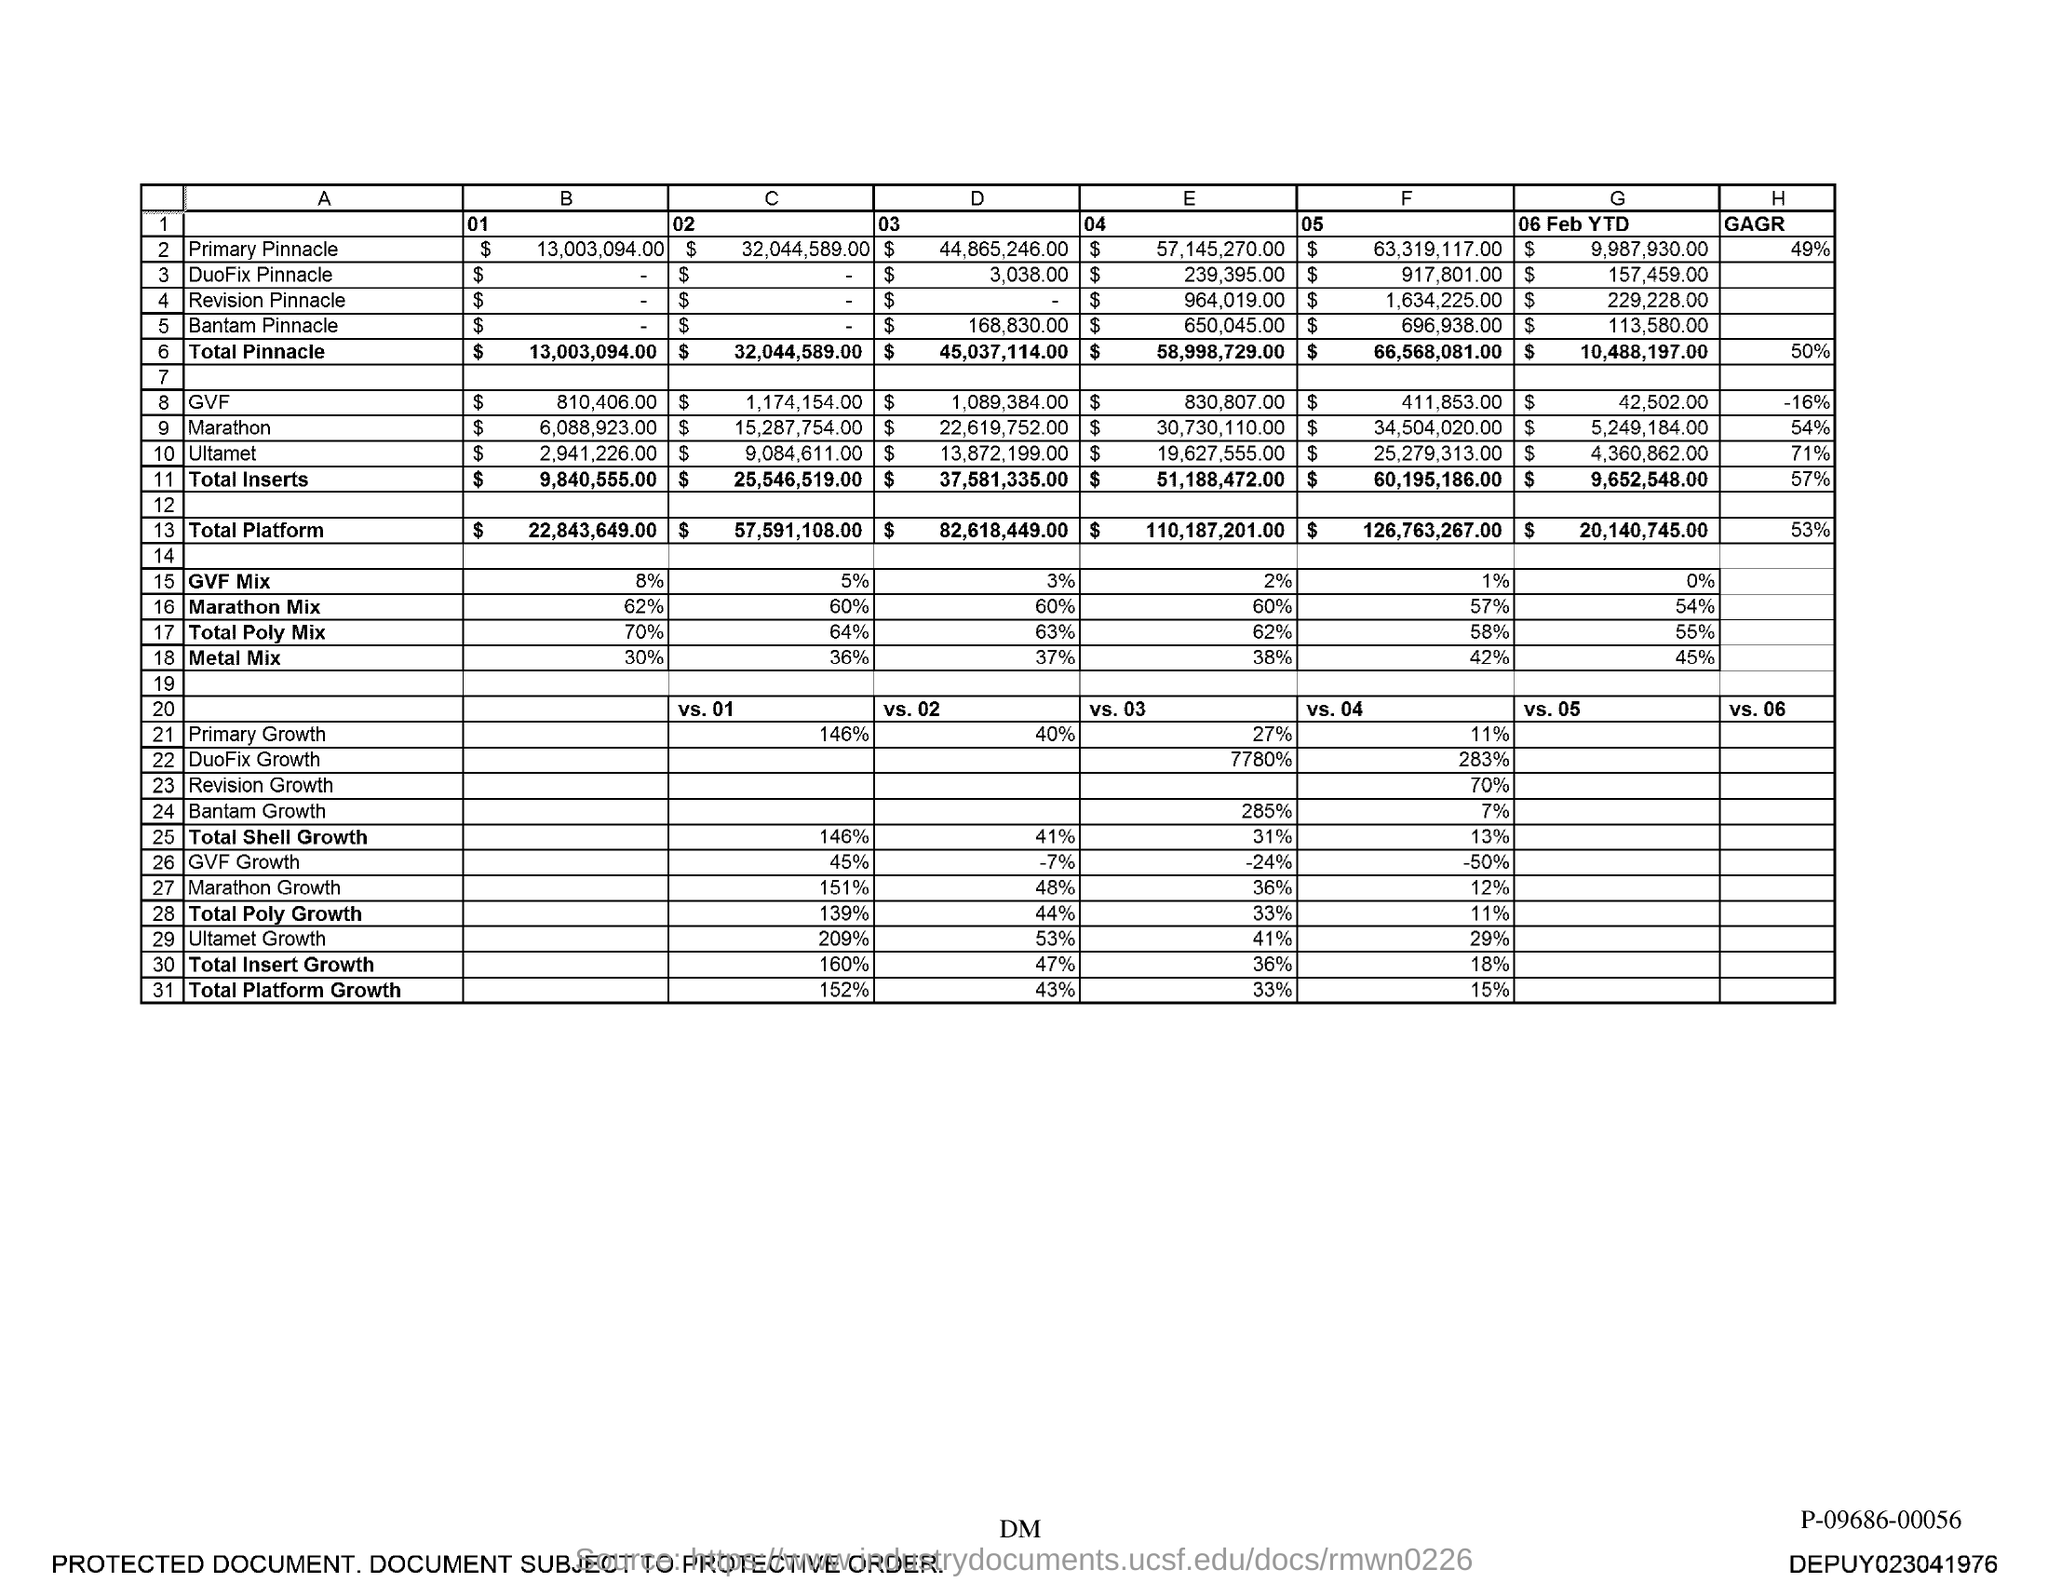What is the "D" "03" value for Primary Pinnacle?
Keep it short and to the point. $44,865,246.00. What is the "D" "03" value for Duofix Pinnacle?
Provide a succinct answer. $ 3,038.00. What is the "D" "03" value for Bantam Pinnacle?
Provide a short and direct response. $168,830.00. What is the "E" "04" value for Primary Pinnacle?
Keep it short and to the point. $57,145,270.00. What is the "E" "04" value for Duofix Pinnacle?
Give a very brief answer. $239,395.00. What is the "E" "04" value for Revision Pinnacle?
Your response must be concise. $964,019.00. What is the "E" "04" value for Bantam Pinnacle?
Give a very brief answer. $ 650,045.00. What is the "E" "04" value for Total Pinnacle?
Ensure brevity in your answer.  $ 58,998,729.00. What is the "F" "05" value for Primary Pinnacle?
Your answer should be very brief. $ 63,319,117.00. 